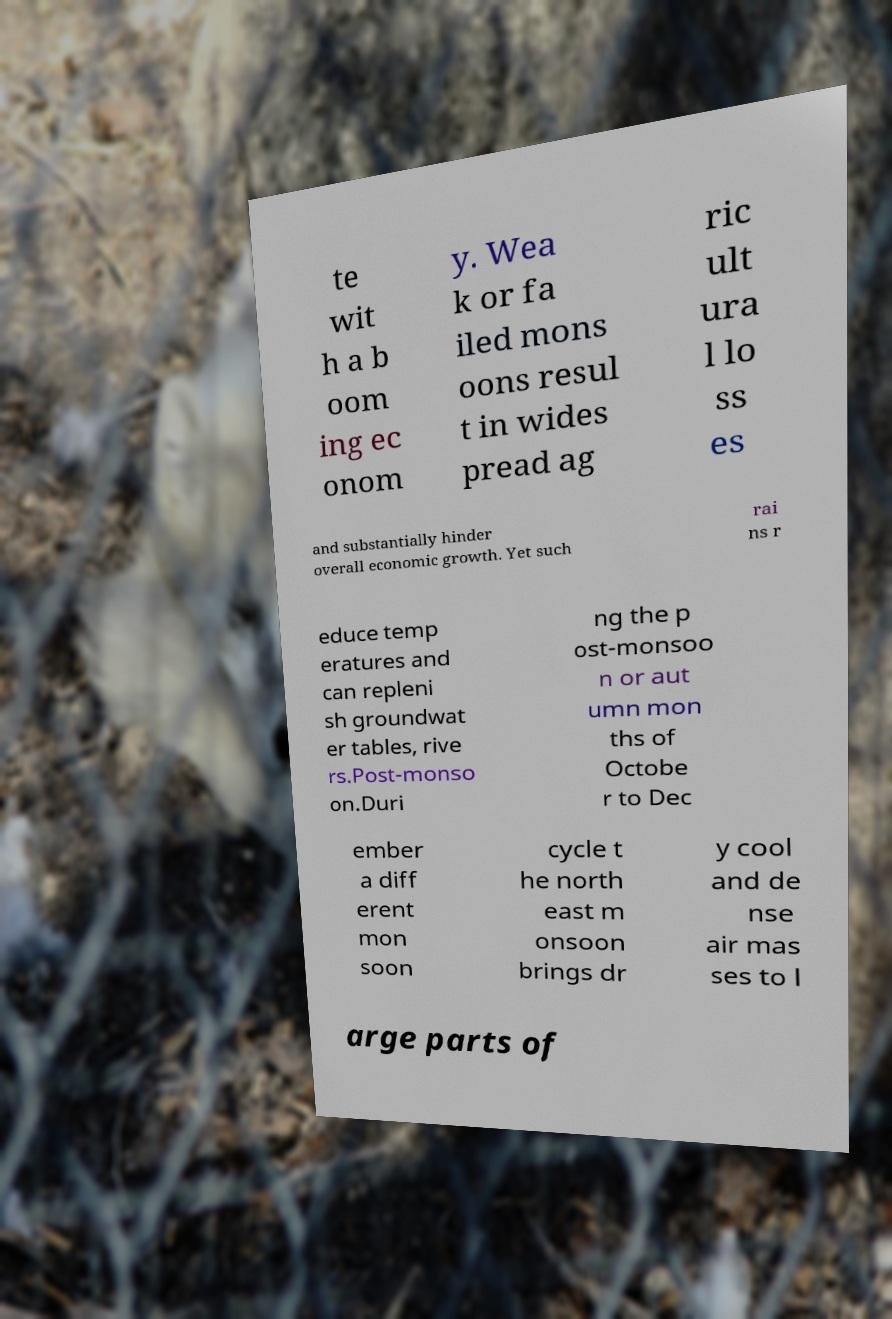There's text embedded in this image that I need extracted. Can you transcribe it verbatim? te wit h a b oom ing ec onom y. Wea k or fa iled mons oons resul t in wides pread ag ric ult ura l lo ss es and substantially hinder overall economic growth. Yet such rai ns r educe temp eratures and can repleni sh groundwat er tables, rive rs.Post-monso on.Duri ng the p ost-monsoo n or aut umn mon ths of Octobe r to Dec ember a diff erent mon soon cycle t he north east m onsoon brings dr y cool and de nse air mas ses to l arge parts of 